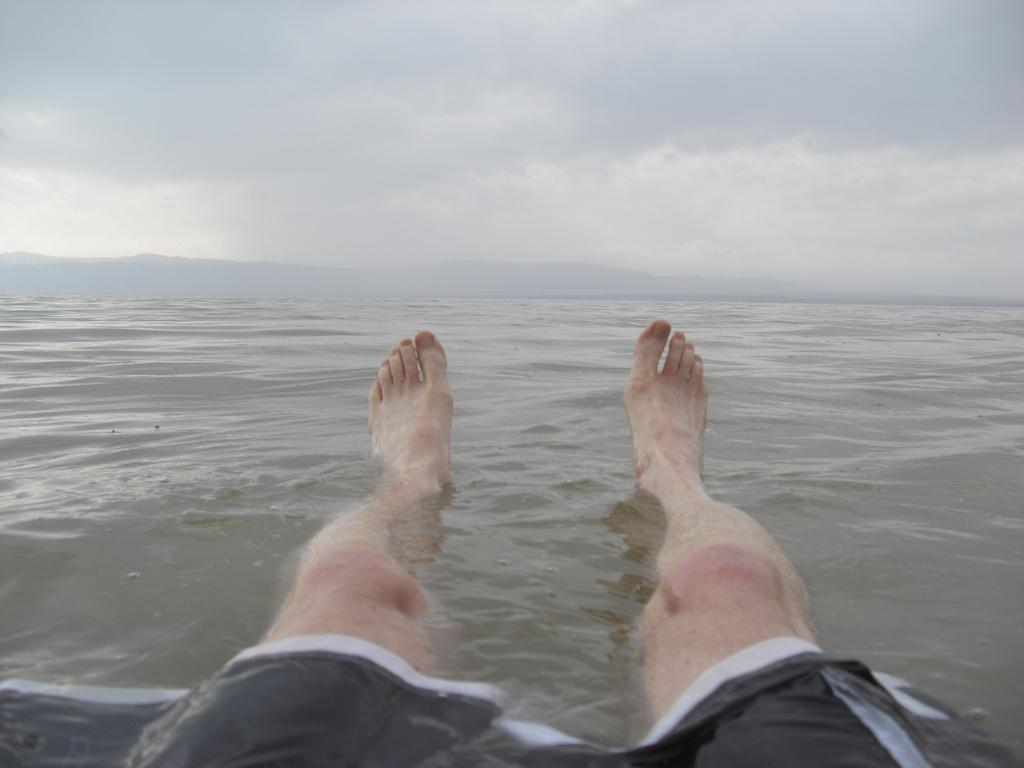What part of a person can be seen in the water in the image? There are legs of a person visible in the water. What can be seen in the background of the image? There is a sky visible in the background of the image. What type of plate is being used to catch the sleet in the image? There is no plate or sleet present in the image; it features a person's legs in the water and a sky in the background. Who is the partner of the person in the water in the image? There is no indication of a partner or any other person in the image; it only shows a person's legs in the water and a sky in the background. 